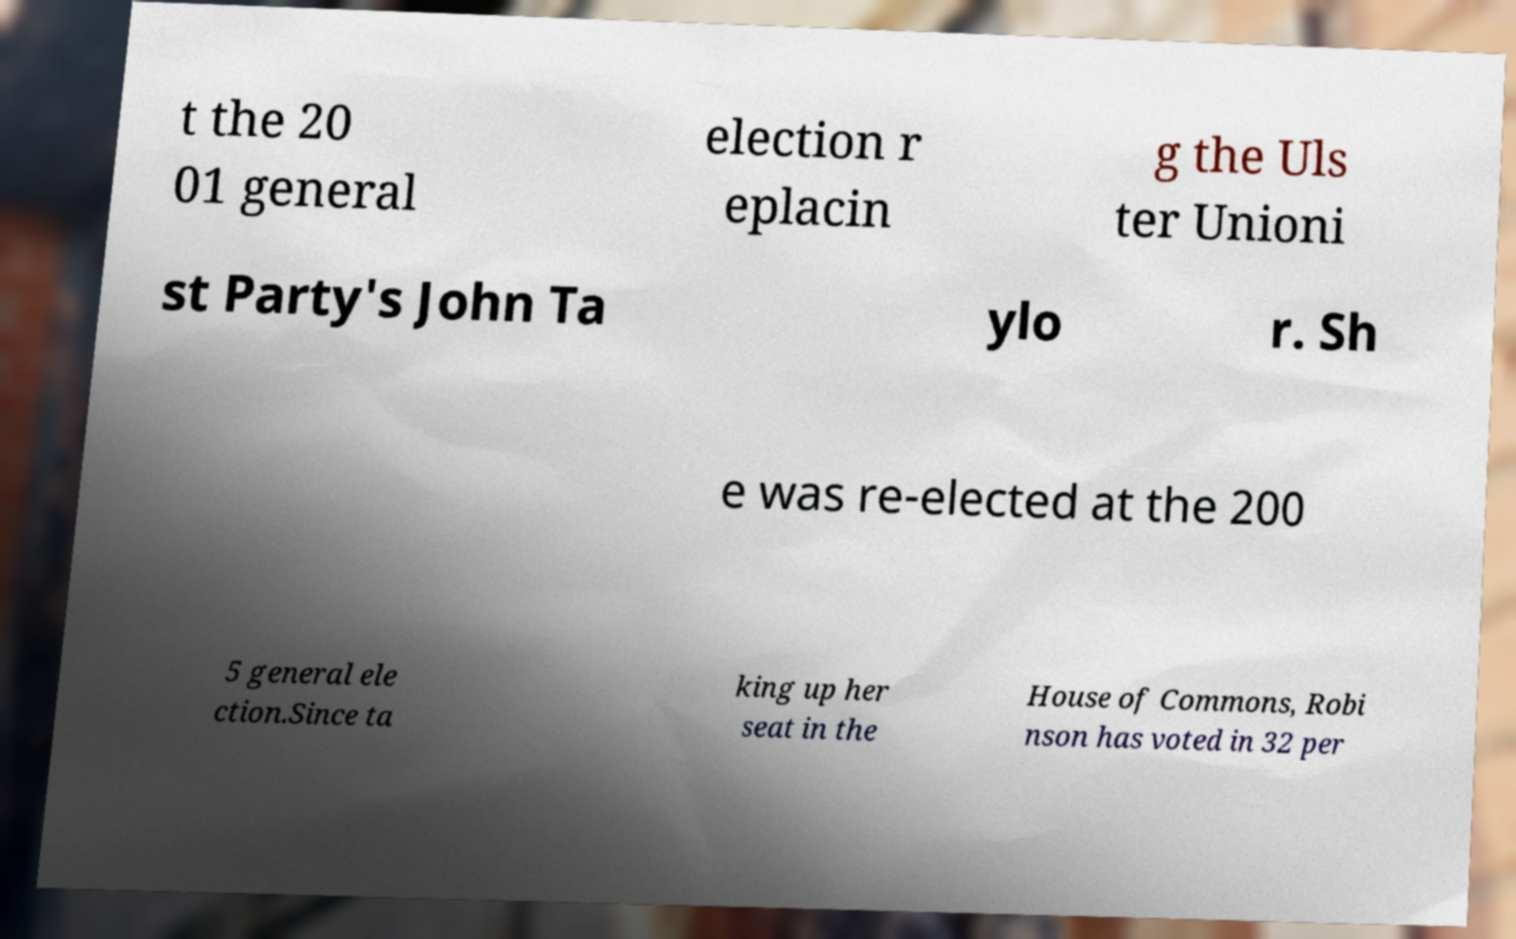Please identify and transcribe the text found in this image. t the 20 01 general election r eplacin g the Uls ter Unioni st Party's John Ta ylo r. Sh e was re-elected at the 200 5 general ele ction.Since ta king up her seat in the House of Commons, Robi nson has voted in 32 per 